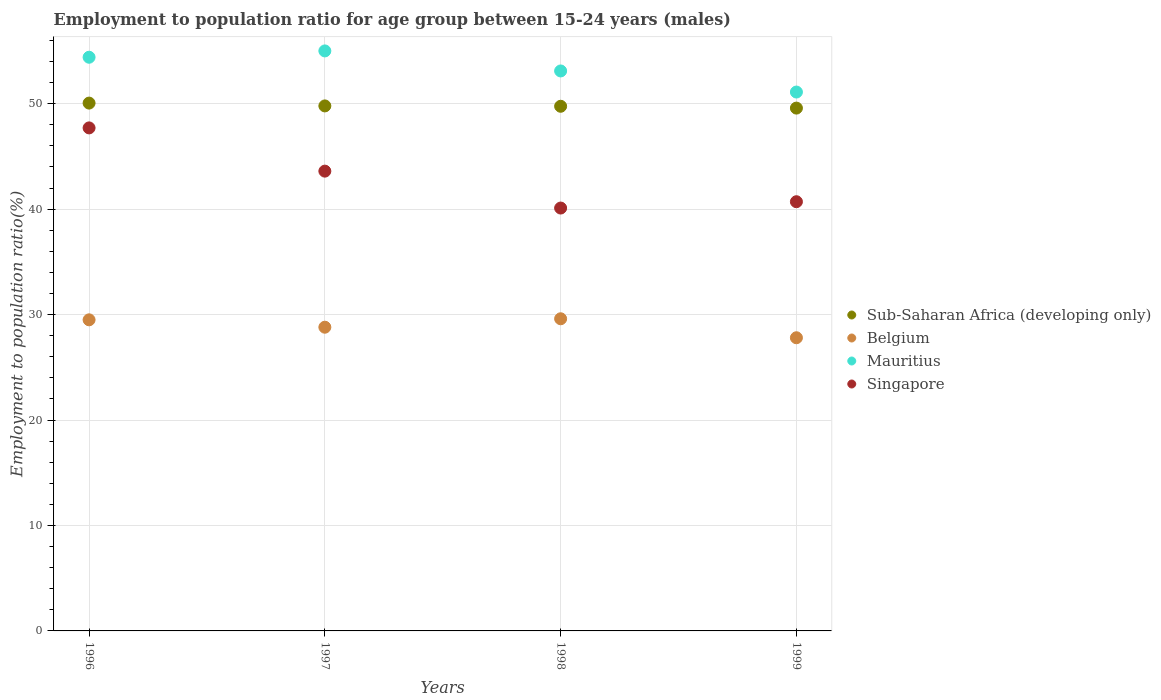How many different coloured dotlines are there?
Your answer should be very brief. 4. What is the employment to population ratio in Singapore in 1998?
Offer a terse response. 40.1. Across all years, what is the maximum employment to population ratio in Belgium?
Your answer should be compact. 29.6. Across all years, what is the minimum employment to population ratio in Mauritius?
Offer a terse response. 51.1. In which year was the employment to population ratio in Belgium maximum?
Your answer should be compact. 1998. What is the total employment to population ratio in Singapore in the graph?
Provide a short and direct response. 172.1. What is the difference between the employment to population ratio in Mauritius in 1996 and that in 1998?
Offer a very short reply. 1.3. What is the difference between the employment to population ratio in Singapore in 1998 and the employment to population ratio in Sub-Saharan Africa (developing only) in 1996?
Ensure brevity in your answer.  -9.95. What is the average employment to population ratio in Sub-Saharan Africa (developing only) per year?
Keep it short and to the point. 49.79. In the year 1998, what is the difference between the employment to population ratio in Sub-Saharan Africa (developing only) and employment to population ratio in Mauritius?
Your response must be concise. -3.35. What is the ratio of the employment to population ratio in Sub-Saharan Africa (developing only) in 1996 to that in 1998?
Your answer should be very brief. 1.01. Is the employment to population ratio in Belgium in 1998 less than that in 1999?
Offer a very short reply. No. Is the difference between the employment to population ratio in Sub-Saharan Africa (developing only) in 1997 and 1998 greater than the difference between the employment to population ratio in Mauritius in 1997 and 1998?
Give a very brief answer. No. What is the difference between the highest and the second highest employment to population ratio in Belgium?
Keep it short and to the point. 0.1. What is the difference between the highest and the lowest employment to population ratio in Singapore?
Give a very brief answer. 7.6. Is the sum of the employment to population ratio in Mauritius in 1996 and 1997 greater than the maximum employment to population ratio in Belgium across all years?
Keep it short and to the point. Yes. Is it the case that in every year, the sum of the employment to population ratio in Mauritius and employment to population ratio in Singapore  is greater than the sum of employment to population ratio in Sub-Saharan Africa (developing only) and employment to population ratio in Belgium?
Offer a terse response. No. Does the employment to population ratio in Sub-Saharan Africa (developing only) monotonically increase over the years?
Keep it short and to the point. No. Is the employment to population ratio in Singapore strictly greater than the employment to population ratio in Belgium over the years?
Provide a short and direct response. Yes. What is the difference between two consecutive major ticks on the Y-axis?
Ensure brevity in your answer.  10. Does the graph contain any zero values?
Offer a terse response. No. What is the title of the graph?
Keep it short and to the point. Employment to population ratio for age group between 15-24 years (males). What is the Employment to population ratio(%) in Sub-Saharan Africa (developing only) in 1996?
Ensure brevity in your answer.  50.05. What is the Employment to population ratio(%) in Belgium in 1996?
Provide a succinct answer. 29.5. What is the Employment to population ratio(%) in Mauritius in 1996?
Give a very brief answer. 54.4. What is the Employment to population ratio(%) of Singapore in 1996?
Ensure brevity in your answer.  47.7. What is the Employment to population ratio(%) in Sub-Saharan Africa (developing only) in 1997?
Keep it short and to the point. 49.78. What is the Employment to population ratio(%) in Belgium in 1997?
Keep it short and to the point. 28.8. What is the Employment to population ratio(%) in Singapore in 1997?
Your response must be concise. 43.6. What is the Employment to population ratio(%) of Sub-Saharan Africa (developing only) in 1998?
Keep it short and to the point. 49.75. What is the Employment to population ratio(%) of Belgium in 1998?
Make the answer very short. 29.6. What is the Employment to population ratio(%) of Mauritius in 1998?
Give a very brief answer. 53.1. What is the Employment to population ratio(%) of Singapore in 1998?
Your response must be concise. 40.1. What is the Employment to population ratio(%) in Sub-Saharan Africa (developing only) in 1999?
Offer a terse response. 49.58. What is the Employment to population ratio(%) of Belgium in 1999?
Ensure brevity in your answer.  27.8. What is the Employment to population ratio(%) in Mauritius in 1999?
Make the answer very short. 51.1. What is the Employment to population ratio(%) in Singapore in 1999?
Give a very brief answer. 40.7. Across all years, what is the maximum Employment to population ratio(%) of Sub-Saharan Africa (developing only)?
Offer a very short reply. 50.05. Across all years, what is the maximum Employment to population ratio(%) of Belgium?
Offer a very short reply. 29.6. Across all years, what is the maximum Employment to population ratio(%) of Mauritius?
Provide a succinct answer. 55. Across all years, what is the maximum Employment to population ratio(%) in Singapore?
Your answer should be compact. 47.7. Across all years, what is the minimum Employment to population ratio(%) of Sub-Saharan Africa (developing only)?
Your response must be concise. 49.58. Across all years, what is the minimum Employment to population ratio(%) in Belgium?
Your answer should be very brief. 27.8. Across all years, what is the minimum Employment to population ratio(%) of Mauritius?
Provide a short and direct response. 51.1. Across all years, what is the minimum Employment to population ratio(%) of Singapore?
Your response must be concise. 40.1. What is the total Employment to population ratio(%) of Sub-Saharan Africa (developing only) in the graph?
Ensure brevity in your answer.  199.17. What is the total Employment to population ratio(%) in Belgium in the graph?
Your answer should be very brief. 115.7. What is the total Employment to population ratio(%) of Mauritius in the graph?
Ensure brevity in your answer.  213.6. What is the total Employment to population ratio(%) of Singapore in the graph?
Ensure brevity in your answer.  172.1. What is the difference between the Employment to population ratio(%) in Sub-Saharan Africa (developing only) in 1996 and that in 1997?
Keep it short and to the point. 0.27. What is the difference between the Employment to population ratio(%) of Mauritius in 1996 and that in 1997?
Give a very brief answer. -0.6. What is the difference between the Employment to population ratio(%) of Sub-Saharan Africa (developing only) in 1996 and that in 1998?
Ensure brevity in your answer.  0.3. What is the difference between the Employment to population ratio(%) of Mauritius in 1996 and that in 1998?
Provide a succinct answer. 1.3. What is the difference between the Employment to population ratio(%) in Sub-Saharan Africa (developing only) in 1996 and that in 1999?
Make the answer very short. 0.47. What is the difference between the Employment to population ratio(%) in Belgium in 1996 and that in 1999?
Your response must be concise. 1.7. What is the difference between the Employment to population ratio(%) in Mauritius in 1996 and that in 1999?
Provide a succinct answer. 3.3. What is the difference between the Employment to population ratio(%) in Singapore in 1996 and that in 1999?
Give a very brief answer. 7. What is the difference between the Employment to population ratio(%) of Sub-Saharan Africa (developing only) in 1997 and that in 1998?
Your response must be concise. 0.03. What is the difference between the Employment to population ratio(%) of Belgium in 1997 and that in 1998?
Make the answer very short. -0.8. What is the difference between the Employment to population ratio(%) in Sub-Saharan Africa (developing only) in 1997 and that in 1999?
Provide a short and direct response. 0.21. What is the difference between the Employment to population ratio(%) in Belgium in 1997 and that in 1999?
Keep it short and to the point. 1. What is the difference between the Employment to population ratio(%) of Singapore in 1997 and that in 1999?
Give a very brief answer. 2.9. What is the difference between the Employment to population ratio(%) of Sub-Saharan Africa (developing only) in 1998 and that in 1999?
Ensure brevity in your answer.  0.17. What is the difference between the Employment to population ratio(%) in Sub-Saharan Africa (developing only) in 1996 and the Employment to population ratio(%) in Belgium in 1997?
Provide a succinct answer. 21.25. What is the difference between the Employment to population ratio(%) in Sub-Saharan Africa (developing only) in 1996 and the Employment to population ratio(%) in Mauritius in 1997?
Keep it short and to the point. -4.95. What is the difference between the Employment to population ratio(%) in Sub-Saharan Africa (developing only) in 1996 and the Employment to population ratio(%) in Singapore in 1997?
Ensure brevity in your answer.  6.45. What is the difference between the Employment to population ratio(%) in Belgium in 1996 and the Employment to population ratio(%) in Mauritius in 1997?
Give a very brief answer. -25.5. What is the difference between the Employment to population ratio(%) of Belgium in 1996 and the Employment to population ratio(%) of Singapore in 1997?
Keep it short and to the point. -14.1. What is the difference between the Employment to population ratio(%) in Sub-Saharan Africa (developing only) in 1996 and the Employment to population ratio(%) in Belgium in 1998?
Make the answer very short. 20.45. What is the difference between the Employment to population ratio(%) of Sub-Saharan Africa (developing only) in 1996 and the Employment to population ratio(%) of Mauritius in 1998?
Provide a succinct answer. -3.05. What is the difference between the Employment to population ratio(%) of Sub-Saharan Africa (developing only) in 1996 and the Employment to population ratio(%) of Singapore in 1998?
Provide a succinct answer. 9.95. What is the difference between the Employment to population ratio(%) of Belgium in 1996 and the Employment to population ratio(%) of Mauritius in 1998?
Your answer should be very brief. -23.6. What is the difference between the Employment to population ratio(%) of Mauritius in 1996 and the Employment to population ratio(%) of Singapore in 1998?
Provide a succinct answer. 14.3. What is the difference between the Employment to population ratio(%) of Sub-Saharan Africa (developing only) in 1996 and the Employment to population ratio(%) of Belgium in 1999?
Ensure brevity in your answer.  22.25. What is the difference between the Employment to population ratio(%) of Sub-Saharan Africa (developing only) in 1996 and the Employment to population ratio(%) of Mauritius in 1999?
Ensure brevity in your answer.  -1.05. What is the difference between the Employment to population ratio(%) in Sub-Saharan Africa (developing only) in 1996 and the Employment to population ratio(%) in Singapore in 1999?
Offer a terse response. 9.35. What is the difference between the Employment to population ratio(%) in Belgium in 1996 and the Employment to population ratio(%) in Mauritius in 1999?
Offer a very short reply. -21.6. What is the difference between the Employment to population ratio(%) of Mauritius in 1996 and the Employment to population ratio(%) of Singapore in 1999?
Keep it short and to the point. 13.7. What is the difference between the Employment to population ratio(%) in Sub-Saharan Africa (developing only) in 1997 and the Employment to population ratio(%) in Belgium in 1998?
Ensure brevity in your answer.  20.18. What is the difference between the Employment to population ratio(%) of Sub-Saharan Africa (developing only) in 1997 and the Employment to population ratio(%) of Mauritius in 1998?
Ensure brevity in your answer.  -3.32. What is the difference between the Employment to population ratio(%) in Sub-Saharan Africa (developing only) in 1997 and the Employment to population ratio(%) in Singapore in 1998?
Offer a terse response. 9.68. What is the difference between the Employment to population ratio(%) in Belgium in 1997 and the Employment to population ratio(%) in Mauritius in 1998?
Offer a terse response. -24.3. What is the difference between the Employment to population ratio(%) in Belgium in 1997 and the Employment to population ratio(%) in Singapore in 1998?
Your answer should be compact. -11.3. What is the difference between the Employment to population ratio(%) in Sub-Saharan Africa (developing only) in 1997 and the Employment to population ratio(%) in Belgium in 1999?
Make the answer very short. 21.98. What is the difference between the Employment to population ratio(%) in Sub-Saharan Africa (developing only) in 1997 and the Employment to population ratio(%) in Mauritius in 1999?
Give a very brief answer. -1.32. What is the difference between the Employment to population ratio(%) of Sub-Saharan Africa (developing only) in 1997 and the Employment to population ratio(%) of Singapore in 1999?
Offer a very short reply. 9.08. What is the difference between the Employment to population ratio(%) of Belgium in 1997 and the Employment to population ratio(%) of Mauritius in 1999?
Your answer should be very brief. -22.3. What is the difference between the Employment to population ratio(%) of Belgium in 1997 and the Employment to population ratio(%) of Singapore in 1999?
Ensure brevity in your answer.  -11.9. What is the difference between the Employment to population ratio(%) in Mauritius in 1997 and the Employment to population ratio(%) in Singapore in 1999?
Ensure brevity in your answer.  14.3. What is the difference between the Employment to population ratio(%) of Sub-Saharan Africa (developing only) in 1998 and the Employment to population ratio(%) of Belgium in 1999?
Make the answer very short. 21.95. What is the difference between the Employment to population ratio(%) of Sub-Saharan Africa (developing only) in 1998 and the Employment to population ratio(%) of Mauritius in 1999?
Give a very brief answer. -1.35. What is the difference between the Employment to population ratio(%) of Sub-Saharan Africa (developing only) in 1998 and the Employment to population ratio(%) of Singapore in 1999?
Provide a succinct answer. 9.05. What is the difference between the Employment to population ratio(%) of Belgium in 1998 and the Employment to population ratio(%) of Mauritius in 1999?
Your answer should be compact. -21.5. What is the difference between the Employment to population ratio(%) of Belgium in 1998 and the Employment to population ratio(%) of Singapore in 1999?
Your response must be concise. -11.1. What is the average Employment to population ratio(%) of Sub-Saharan Africa (developing only) per year?
Give a very brief answer. 49.79. What is the average Employment to population ratio(%) in Belgium per year?
Give a very brief answer. 28.93. What is the average Employment to population ratio(%) in Mauritius per year?
Ensure brevity in your answer.  53.4. What is the average Employment to population ratio(%) of Singapore per year?
Provide a succinct answer. 43.02. In the year 1996, what is the difference between the Employment to population ratio(%) in Sub-Saharan Africa (developing only) and Employment to population ratio(%) in Belgium?
Offer a very short reply. 20.55. In the year 1996, what is the difference between the Employment to population ratio(%) of Sub-Saharan Africa (developing only) and Employment to population ratio(%) of Mauritius?
Make the answer very short. -4.35. In the year 1996, what is the difference between the Employment to population ratio(%) of Sub-Saharan Africa (developing only) and Employment to population ratio(%) of Singapore?
Ensure brevity in your answer.  2.35. In the year 1996, what is the difference between the Employment to population ratio(%) of Belgium and Employment to population ratio(%) of Mauritius?
Your response must be concise. -24.9. In the year 1996, what is the difference between the Employment to population ratio(%) of Belgium and Employment to population ratio(%) of Singapore?
Offer a terse response. -18.2. In the year 1996, what is the difference between the Employment to population ratio(%) in Mauritius and Employment to population ratio(%) in Singapore?
Your response must be concise. 6.7. In the year 1997, what is the difference between the Employment to population ratio(%) in Sub-Saharan Africa (developing only) and Employment to population ratio(%) in Belgium?
Offer a very short reply. 20.98. In the year 1997, what is the difference between the Employment to population ratio(%) of Sub-Saharan Africa (developing only) and Employment to population ratio(%) of Mauritius?
Your response must be concise. -5.22. In the year 1997, what is the difference between the Employment to population ratio(%) in Sub-Saharan Africa (developing only) and Employment to population ratio(%) in Singapore?
Provide a short and direct response. 6.18. In the year 1997, what is the difference between the Employment to population ratio(%) in Belgium and Employment to population ratio(%) in Mauritius?
Ensure brevity in your answer.  -26.2. In the year 1997, what is the difference between the Employment to population ratio(%) in Belgium and Employment to population ratio(%) in Singapore?
Keep it short and to the point. -14.8. In the year 1997, what is the difference between the Employment to population ratio(%) in Mauritius and Employment to population ratio(%) in Singapore?
Give a very brief answer. 11.4. In the year 1998, what is the difference between the Employment to population ratio(%) of Sub-Saharan Africa (developing only) and Employment to population ratio(%) of Belgium?
Offer a terse response. 20.15. In the year 1998, what is the difference between the Employment to population ratio(%) in Sub-Saharan Africa (developing only) and Employment to population ratio(%) in Mauritius?
Offer a very short reply. -3.35. In the year 1998, what is the difference between the Employment to population ratio(%) in Sub-Saharan Africa (developing only) and Employment to population ratio(%) in Singapore?
Provide a succinct answer. 9.65. In the year 1998, what is the difference between the Employment to population ratio(%) of Belgium and Employment to population ratio(%) of Mauritius?
Provide a succinct answer. -23.5. In the year 1998, what is the difference between the Employment to population ratio(%) in Belgium and Employment to population ratio(%) in Singapore?
Give a very brief answer. -10.5. In the year 1999, what is the difference between the Employment to population ratio(%) in Sub-Saharan Africa (developing only) and Employment to population ratio(%) in Belgium?
Offer a terse response. 21.78. In the year 1999, what is the difference between the Employment to population ratio(%) of Sub-Saharan Africa (developing only) and Employment to population ratio(%) of Mauritius?
Your response must be concise. -1.52. In the year 1999, what is the difference between the Employment to population ratio(%) of Sub-Saharan Africa (developing only) and Employment to population ratio(%) of Singapore?
Offer a terse response. 8.88. In the year 1999, what is the difference between the Employment to population ratio(%) of Belgium and Employment to population ratio(%) of Mauritius?
Give a very brief answer. -23.3. In the year 1999, what is the difference between the Employment to population ratio(%) of Belgium and Employment to population ratio(%) of Singapore?
Give a very brief answer. -12.9. In the year 1999, what is the difference between the Employment to population ratio(%) of Mauritius and Employment to population ratio(%) of Singapore?
Your answer should be very brief. 10.4. What is the ratio of the Employment to population ratio(%) of Sub-Saharan Africa (developing only) in 1996 to that in 1997?
Provide a succinct answer. 1.01. What is the ratio of the Employment to population ratio(%) in Belgium in 1996 to that in 1997?
Offer a terse response. 1.02. What is the ratio of the Employment to population ratio(%) in Singapore in 1996 to that in 1997?
Make the answer very short. 1.09. What is the ratio of the Employment to population ratio(%) of Belgium in 1996 to that in 1998?
Your response must be concise. 1. What is the ratio of the Employment to population ratio(%) in Mauritius in 1996 to that in 1998?
Provide a short and direct response. 1.02. What is the ratio of the Employment to population ratio(%) of Singapore in 1996 to that in 1998?
Offer a very short reply. 1.19. What is the ratio of the Employment to population ratio(%) in Sub-Saharan Africa (developing only) in 1996 to that in 1999?
Offer a very short reply. 1.01. What is the ratio of the Employment to population ratio(%) of Belgium in 1996 to that in 1999?
Provide a succinct answer. 1.06. What is the ratio of the Employment to population ratio(%) of Mauritius in 1996 to that in 1999?
Your answer should be compact. 1.06. What is the ratio of the Employment to population ratio(%) of Singapore in 1996 to that in 1999?
Your answer should be compact. 1.17. What is the ratio of the Employment to population ratio(%) of Belgium in 1997 to that in 1998?
Your response must be concise. 0.97. What is the ratio of the Employment to population ratio(%) in Mauritius in 1997 to that in 1998?
Your answer should be compact. 1.04. What is the ratio of the Employment to population ratio(%) of Singapore in 1997 to that in 1998?
Make the answer very short. 1.09. What is the ratio of the Employment to population ratio(%) of Sub-Saharan Africa (developing only) in 1997 to that in 1999?
Give a very brief answer. 1. What is the ratio of the Employment to population ratio(%) of Belgium in 1997 to that in 1999?
Offer a very short reply. 1.04. What is the ratio of the Employment to population ratio(%) in Mauritius in 1997 to that in 1999?
Provide a short and direct response. 1.08. What is the ratio of the Employment to population ratio(%) in Singapore in 1997 to that in 1999?
Offer a very short reply. 1.07. What is the ratio of the Employment to population ratio(%) in Belgium in 1998 to that in 1999?
Your answer should be compact. 1.06. What is the ratio of the Employment to population ratio(%) in Mauritius in 1998 to that in 1999?
Give a very brief answer. 1.04. What is the difference between the highest and the second highest Employment to population ratio(%) of Sub-Saharan Africa (developing only)?
Ensure brevity in your answer.  0.27. What is the difference between the highest and the second highest Employment to population ratio(%) of Belgium?
Your answer should be very brief. 0.1. What is the difference between the highest and the second highest Employment to population ratio(%) of Singapore?
Your answer should be very brief. 4.1. What is the difference between the highest and the lowest Employment to population ratio(%) in Sub-Saharan Africa (developing only)?
Ensure brevity in your answer.  0.47. What is the difference between the highest and the lowest Employment to population ratio(%) in Belgium?
Give a very brief answer. 1.8. What is the difference between the highest and the lowest Employment to population ratio(%) of Mauritius?
Ensure brevity in your answer.  3.9. 